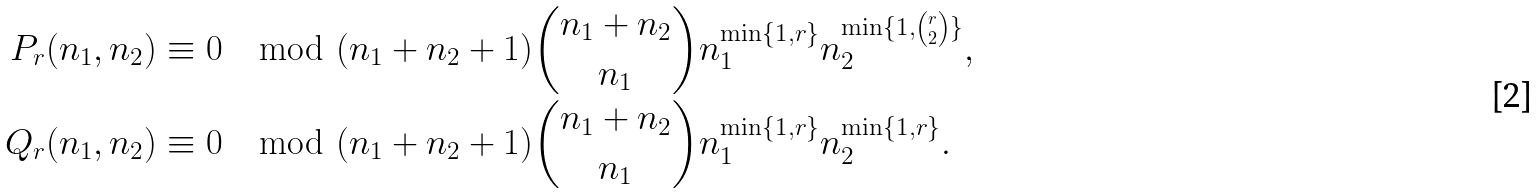<formula> <loc_0><loc_0><loc_500><loc_500>P _ { r } ( n _ { 1 } , n _ { 2 } ) & \equiv 0 \mod ( n _ { 1 } + n _ { 2 } + 1 ) { n _ { 1 } + n _ { 2 } \choose n _ { 1 } } n _ { 1 } ^ { \min \{ 1 , r \} } n _ { 2 } ^ { \min \{ 1 , { r \choose 2 } \} } , \\ Q _ { r } ( n _ { 1 } , n _ { 2 } ) & \equiv 0 \mod ( n _ { 1 } + n _ { 2 } + 1 ) { n _ { 1 } + n _ { 2 } \choose n _ { 1 } } n _ { 1 } ^ { \min \{ 1 , r \} } n _ { 2 } ^ { \min \{ 1 , r \} } .</formula> 